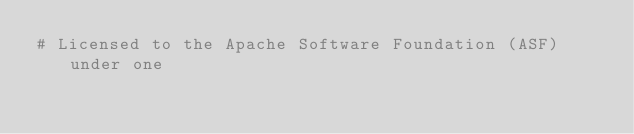Convert code to text. <code><loc_0><loc_0><loc_500><loc_500><_Python_># Licensed to the Apache Software Foundation (ASF) under one</code> 